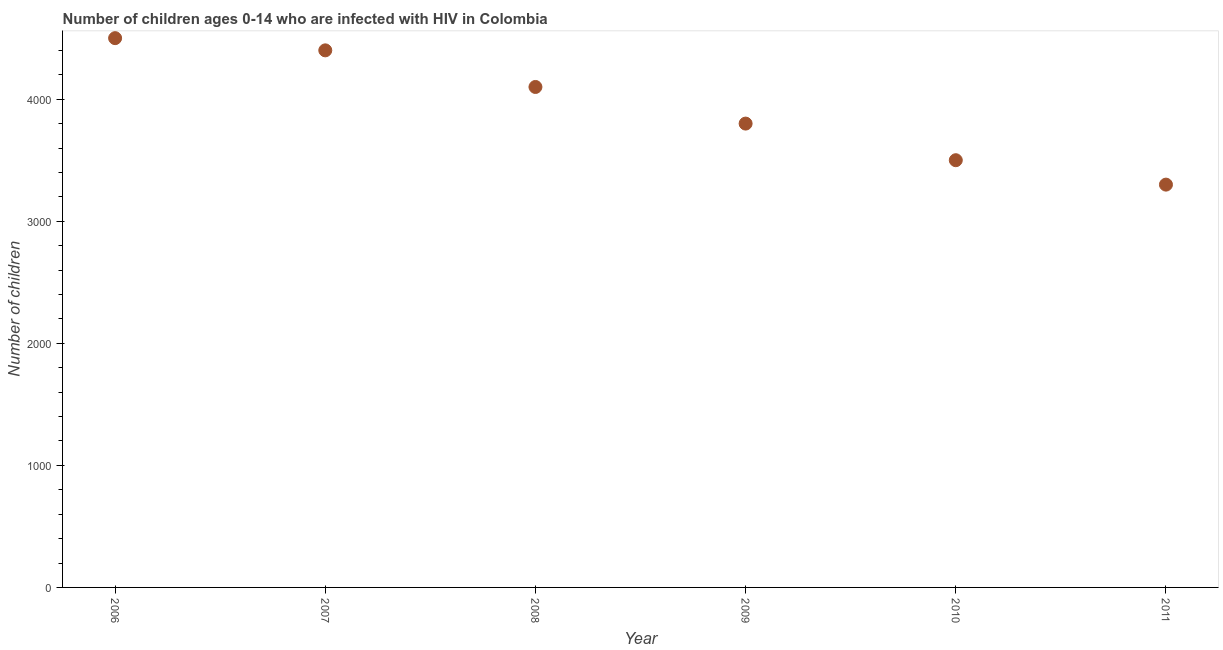What is the number of children living with hiv in 2011?
Your response must be concise. 3300. Across all years, what is the maximum number of children living with hiv?
Provide a succinct answer. 4500. Across all years, what is the minimum number of children living with hiv?
Provide a succinct answer. 3300. In which year was the number of children living with hiv maximum?
Provide a succinct answer. 2006. In which year was the number of children living with hiv minimum?
Give a very brief answer. 2011. What is the sum of the number of children living with hiv?
Give a very brief answer. 2.36e+04. What is the difference between the number of children living with hiv in 2010 and 2011?
Offer a terse response. 200. What is the average number of children living with hiv per year?
Your response must be concise. 3933.33. What is the median number of children living with hiv?
Provide a short and direct response. 3950. In how many years, is the number of children living with hiv greater than 1800 ?
Offer a very short reply. 6. What is the ratio of the number of children living with hiv in 2007 to that in 2010?
Ensure brevity in your answer.  1.26. What is the difference between the highest and the second highest number of children living with hiv?
Provide a short and direct response. 100. Is the sum of the number of children living with hiv in 2007 and 2010 greater than the maximum number of children living with hiv across all years?
Provide a short and direct response. Yes. What is the difference between the highest and the lowest number of children living with hiv?
Make the answer very short. 1200. Does the number of children living with hiv monotonically increase over the years?
Your answer should be very brief. No. How many dotlines are there?
Make the answer very short. 1. How many years are there in the graph?
Provide a short and direct response. 6. Does the graph contain any zero values?
Keep it short and to the point. No. Does the graph contain grids?
Provide a succinct answer. No. What is the title of the graph?
Offer a terse response. Number of children ages 0-14 who are infected with HIV in Colombia. What is the label or title of the X-axis?
Provide a succinct answer. Year. What is the label or title of the Y-axis?
Give a very brief answer. Number of children. What is the Number of children in 2006?
Ensure brevity in your answer.  4500. What is the Number of children in 2007?
Provide a short and direct response. 4400. What is the Number of children in 2008?
Offer a very short reply. 4100. What is the Number of children in 2009?
Provide a short and direct response. 3800. What is the Number of children in 2010?
Offer a very short reply. 3500. What is the Number of children in 2011?
Keep it short and to the point. 3300. What is the difference between the Number of children in 2006 and 2007?
Provide a short and direct response. 100. What is the difference between the Number of children in 2006 and 2009?
Offer a terse response. 700. What is the difference between the Number of children in 2006 and 2011?
Provide a short and direct response. 1200. What is the difference between the Number of children in 2007 and 2008?
Keep it short and to the point. 300. What is the difference between the Number of children in 2007 and 2009?
Keep it short and to the point. 600. What is the difference between the Number of children in 2007 and 2010?
Offer a terse response. 900. What is the difference between the Number of children in 2007 and 2011?
Keep it short and to the point. 1100. What is the difference between the Number of children in 2008 and 2009?
Provide a short and direct response. 300. What is the difference between the Number of children in 2008 and 2010?
Your response must be concise. 600. What is the difference between the Number of children in 2008 and 2011?
Offer a terse response. 800. What is the difference between the Number of children in 2009 and 2010?
Make the answer very short. 300. What is the difference between the Number of children in 2009 and 2011?
Offer a very short reply. 500. What is the ratio of the Number of children in 2006 to that in 2007?
Give a very brief answer. 1.02. What is the ratio of the Number of children in 2006 to that in 2008?
Offer a terse response. 1.1. What is the ratio of the Number of children in 2006 to that in 2009?
Your answer should be very brief. 1.18. What is the ratio of the Number of children in 2006 to that in 2010?
Make the answer very short. 1.29. What is the ratio of the Number of children in 2006 to that in 2011?
Give a very brief answer. 1.36. What is the ratio of the Number of children in 2007 to that in 2008?
Offer a very short reply. 1.07. What is the ratio of the Number of children in 2007 to that in 2009?
Offer a terse response. 1.16. What is the ratio of the Number of children in 2007 to that in 2010?
Give a very brief answer. 1.26. What is the ratio of the Number of children in 2007 to that in 2011?
Your response must be concise. 1.33. What is the ratio of the Number of children in 2008 to that in 2009?
Offer a terse response. 1.08. What is the ratio of the Number of children in 2008 to that in 2010?
Ensure brevity in your answer.  1.17. What is the ratio of the Number of children in 2008 to that in 2011?
Offer a very short reply. 1.24. What is the ratio of the Number of children in 2009 to that in 2010?
Make the answer very short. 1.09. What is the ratio of the Number of children in 2009 to that in 2011?
Make the answer very short. 1.15. What is the ratio of the Number of children in 2010 to that in 2011?
Offer a terse response. 1.06. 